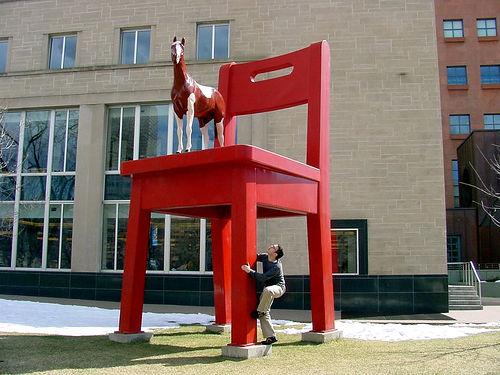What is on top of the seat of the chair?
Concise answer only. Horse. What is the man climbing?
Quick response, please. Chair. What color is the chair?
Keep it brief. Red. 